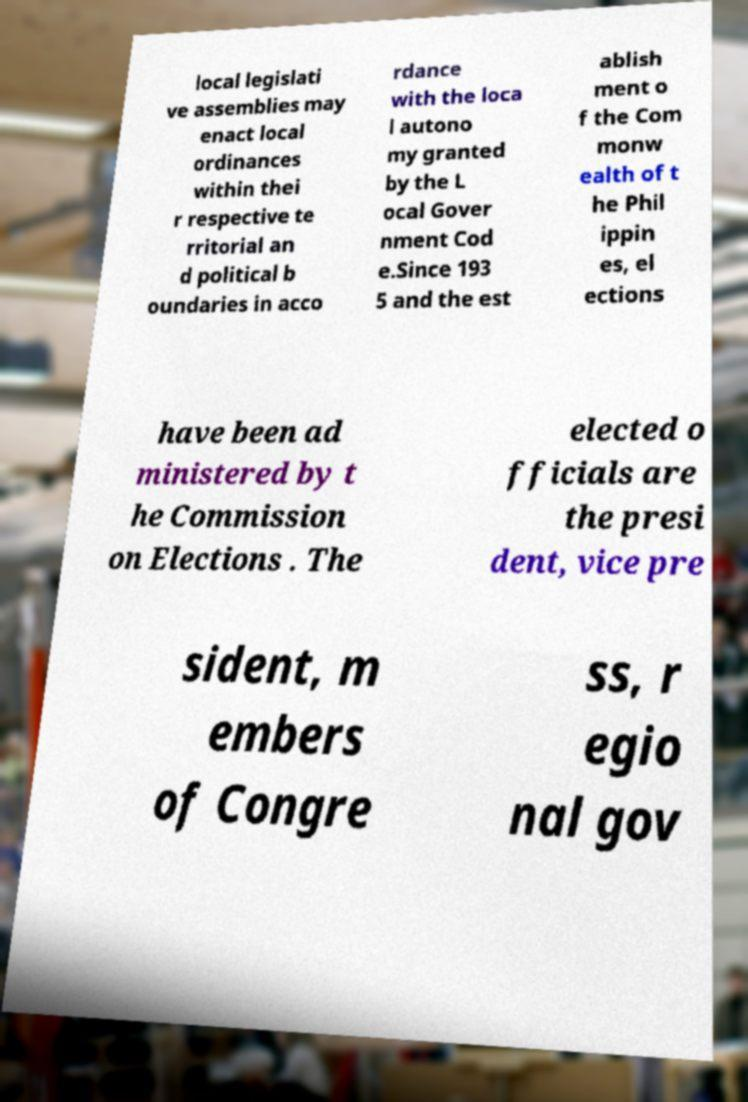There's text embedded in this image that I need extracted. Can you transcribe it verbatim? local legislati ve assemblies may enact local ordinances within thei r respective te rritorial an d political b oundaries in acco rdance with the loca l autono my granted by the L ocal Gover nment Cod e.Since 193 5 and the est ablish ment o f the Com monw ealth of t he Phil ippin es, el ections have been ad ministered by t he Commission on Elections . The elected o fficials are the presi dent, vice pre sident, m embers of Congre ss, r egio nal gov 